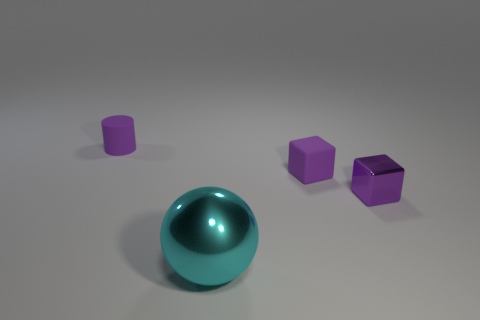Is there any other thing that has the same size as the cyan thing?
Your response must be concise. No. Does the purple matte thing that is in front of the rubber cylinder have the same size as the big metallic ball?
Make the answer very short. No. What number of objects are small purple objects right of the ball or purple things behind the small metallic object?
Keep it short and to the point. 3. There is a small rubber thing that is to the right of the sphere; is its color the same as the tiny cylinder?
Your answer should be compact. Yes. How many matte things are either purple things or large green objects?
Offer a terse response. 2. The tiny purple shiny thing has what shape?
Provide a succinct answer. Cube. Is the material of the large sphere the same as the purple cylinder?
Provide a short and direct response. No. Are there any tiny cylinders in front of the tiny block that is left of the metal object right of the big thing?
Ensure brevity in your answer.  No. How many other things are the same shape as the cyan thing?
Your response must be concise. 0. There is a object that is on the right side of the cyan metallic sphere and behind the tiny purple metallic block; what is its shape?
Make the answer very short. Cube. 